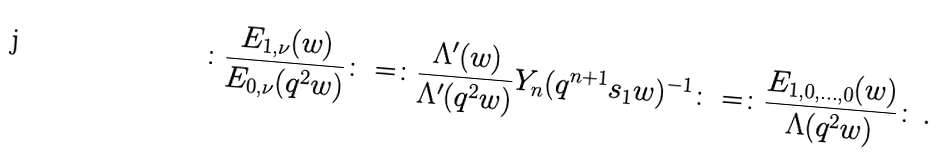<formula> <loc_0><loc_0><loc_500><loc_500>\colon \frac { E _ { 1 , \nu } ( w ) } { E _ { 0 , \nu } ( q ^ { 2 } w ) } \colon = \colon \frac { \Lambda ^ { \prime } ( w ) } { \Lambda ^ { \prime } ( q ^ { 2 } w ) } Y _ { n } ( q ^ { n + 1 } s _ { 1 } w ) ^ { - 1 } \colon = \colon \frac { E _ { 1 , 0 , \dots , 0 } ( w ) } { \Lambda ( q ^ { 2 } w ) } \colon \, .</formula> 